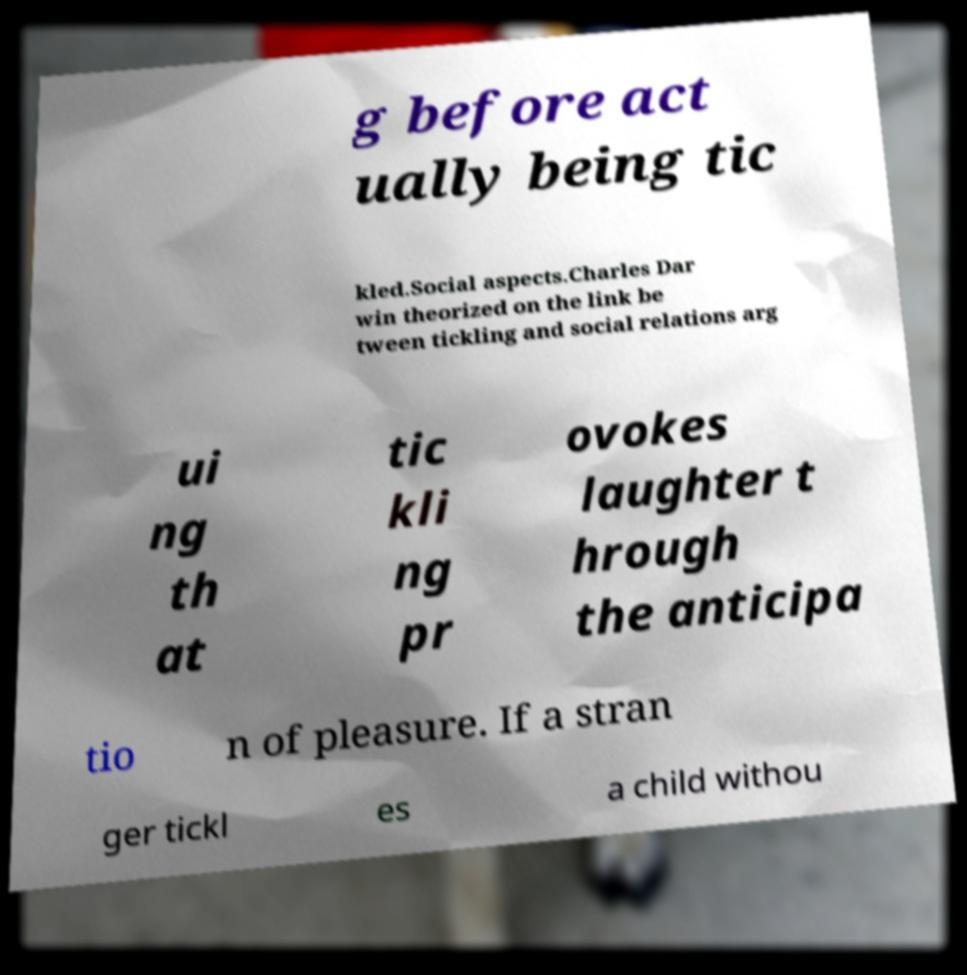I need the written content from this picture converted into text. Can you do that? g before act ually being tic kled.Social aspects.Charles Dar win theorized on the link be tween tickling and social relations arg ui ng th at tic kli ng pr ovokes laughter t hrough the anticipa tio n of pleasure. If a stran ger tickl es a child withou 